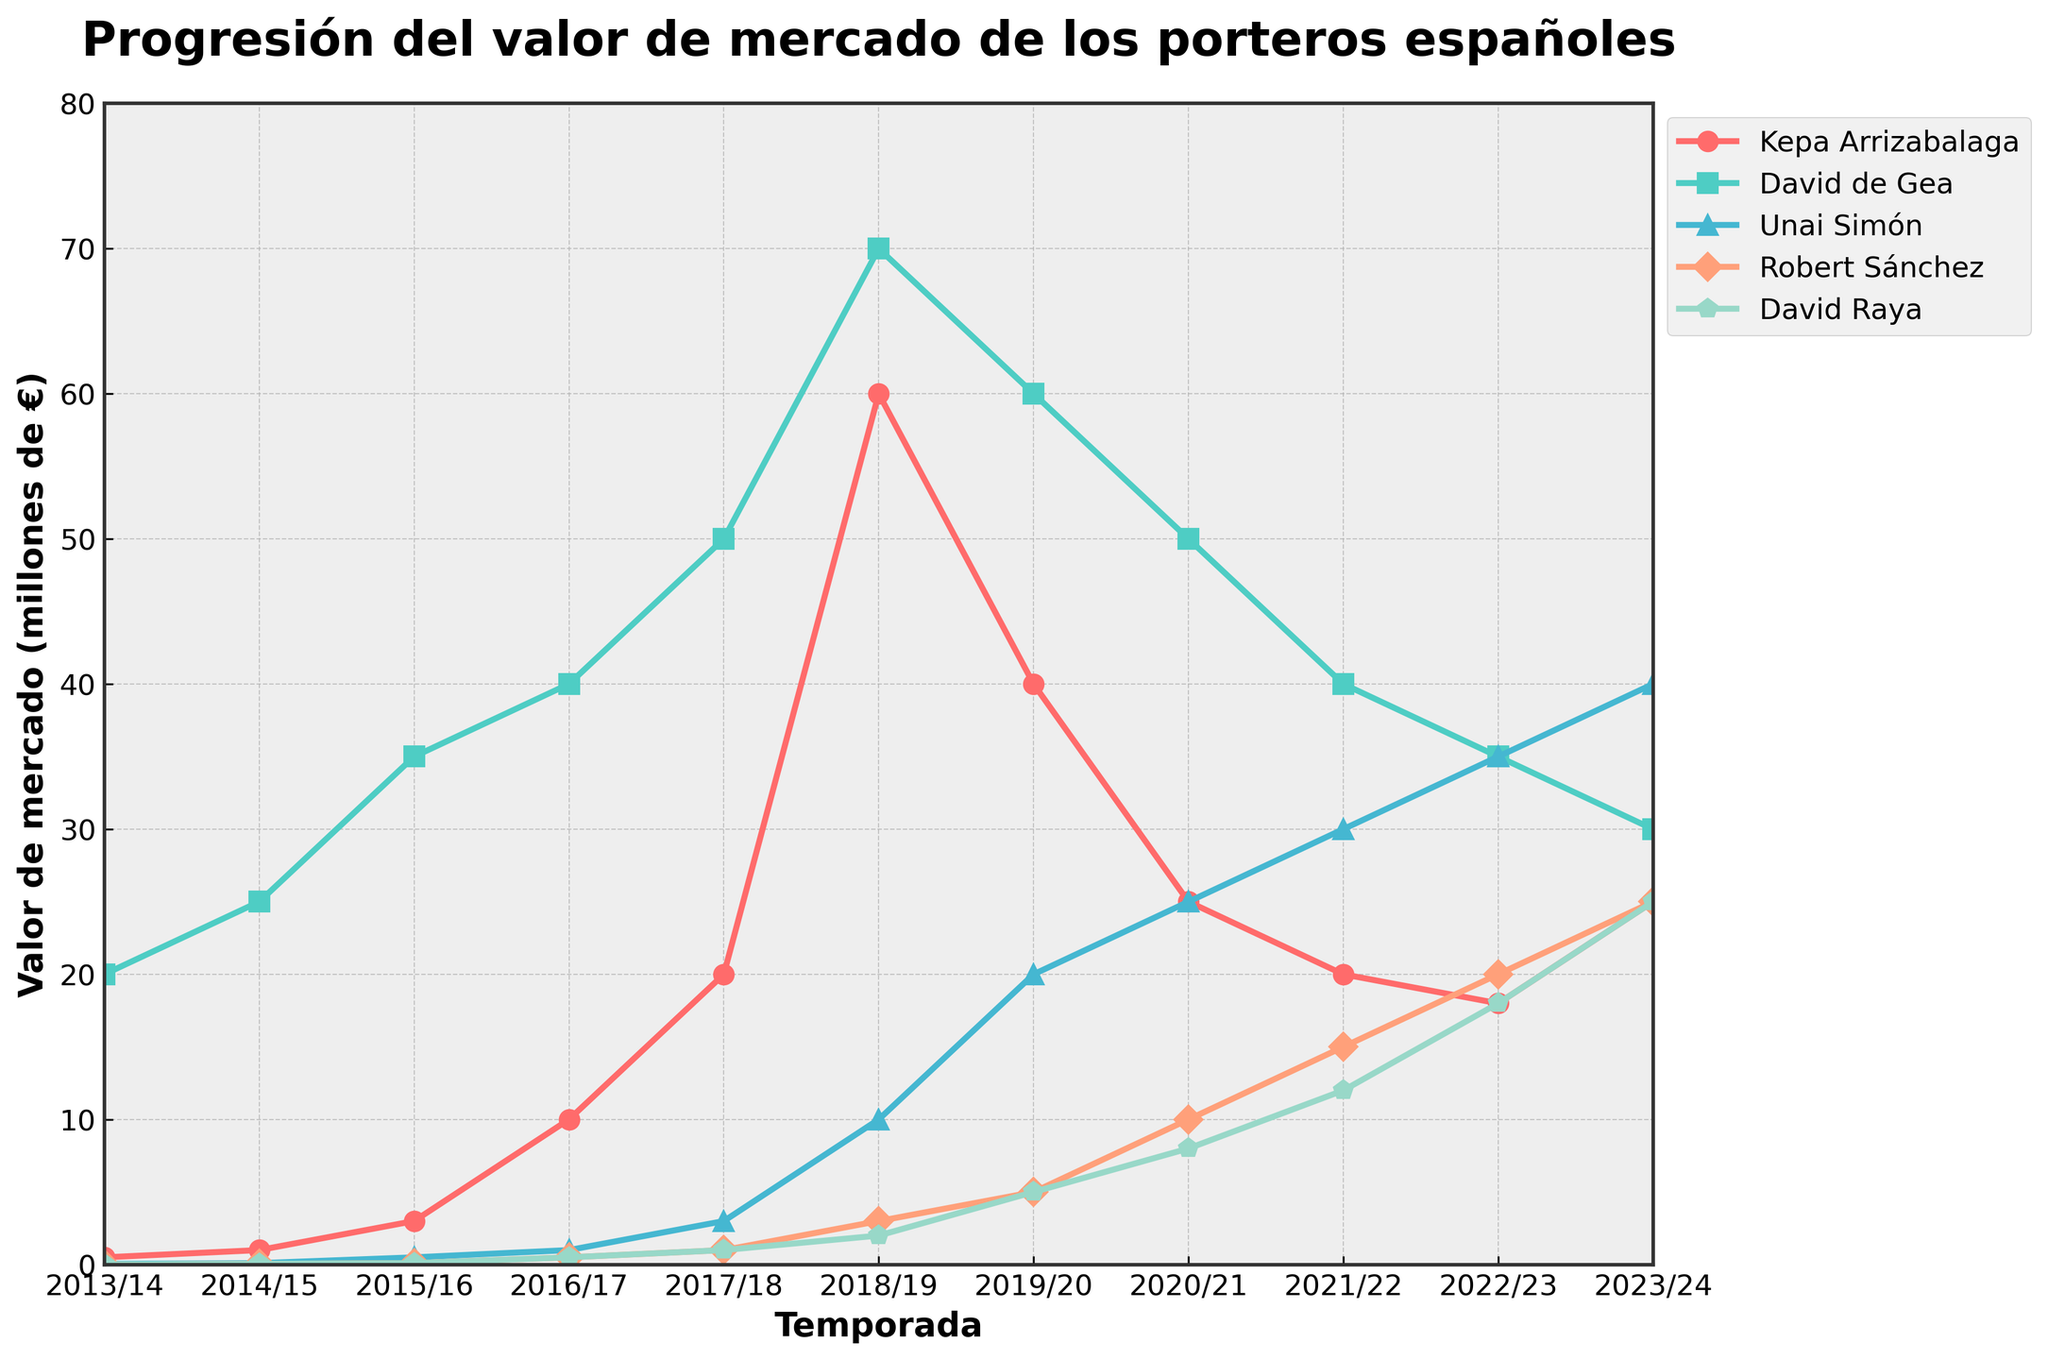Which portero has the highest market value in the 2018/19 season? Look at the values of all porteros for the 2018/19 season. Kepa Arrizabalaga has the highest value of 60 million euros.
Answer: Kepa Arrizabalaga How did the market value of David de Gea change from the 2017/18 season to the 2023/24 season? Note the values of David de Gea in 2017/18 and 2023/24, which are 50 and 30 million euros, respectively. The market value decreased by 20 million euros.
Answer: Decreased by 20 million euros Which portero had the largest increase in market value from the 2019/20 season to the 2020/21 season? Compare the changes in market values of all porteros between 2019/20 and 2020/21. Unai Simón’s market value increased from 20 to 25 million euros, which is the largest increase of 5 million euros.
Answer: Unai Simón What is the average market value of Robert Sánchez over the given seasons? Sum up all the values of Robert Sánchez: 0.01 + 0.05 + 0.1 + 0.5 + 1 + 3 + 5 + 10 + 15 + 20 + 25 = 80.71, then divide by the number of seasons (11).
Answer: 7.34 million euros Among all porteros, who had the highest market value in the 2013/14 season and what was it? Check the values for the 2013/14 season. David de Gea had the highest market value with 20 million euros.
Answer: David de Gea, 20 million euros Between Kepa Arrizabalaga and David Raya, who had a higher market value in the 2020/21 season and by how much? In 2020/21, Kepa Arrizabalaga’s value was 25 million euros, and David Raya’s value was 8 million euros. Kepa had a higher value by 17 million euros.
Answer: Kepa Arrizabalaga by 17 million euros Did Unai Simón’s market value ever surpass David de Gea’s value from 2013/14 to 2023/24? If yes, in which season(s)? Examine the values across seasons for both porteros. Unai Simón's value surpasses David de Gea in the 2022/23 (35 vs. 35 million euros) and 2023/24 (40 vs. 30 million euros) seasons.
Answer: Yes, in 2022/23 and 2023/24 How many times did Robert Sánchez’s market value double compared to the previous season? Track the values of Robert Sánchez season by season and check for doubling: From 2013/14 (0.01), 2014/15 (0.05), 2015/16 (0.1), 2016/17 (0.5), 2017/18 (1), 2018/19 (3), 2019/20 (5), 2020/21 (10), 2021/22 (15), 2022/23 (20), 2023/24 (25). He doubled his value four times (2013/14 to 2014/15, 2015/16 to 2016/17, 2017/18 to 2018/19, and 2019/20 to 2020/21).
Answer: Four times Who has the lowest market value recorded in any season, and what is that value? Review the dataset for the lowest value. Robert Sánchez has the lowest recorded market value at 0.01 million euros in 2013/14.
Answer: Robert Sánchez, 0.01 million euros 